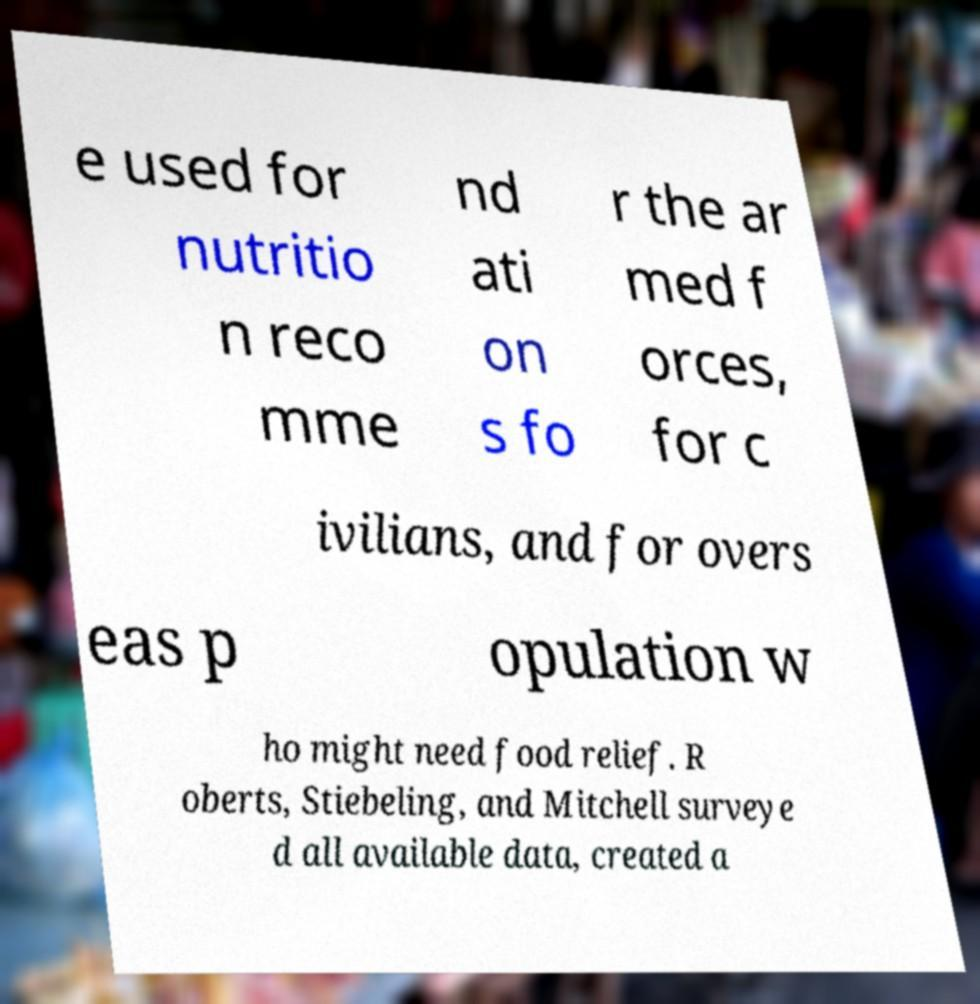Could you extract and type out the text from this image? e used for nutritio n reco mme nd ati on s fo r the ar med f orces, for c ivilians, and for overs eas p opulation w ho might need food relief. R oberts, Stiebeling, and Mitchell surveye d all available data, created a 